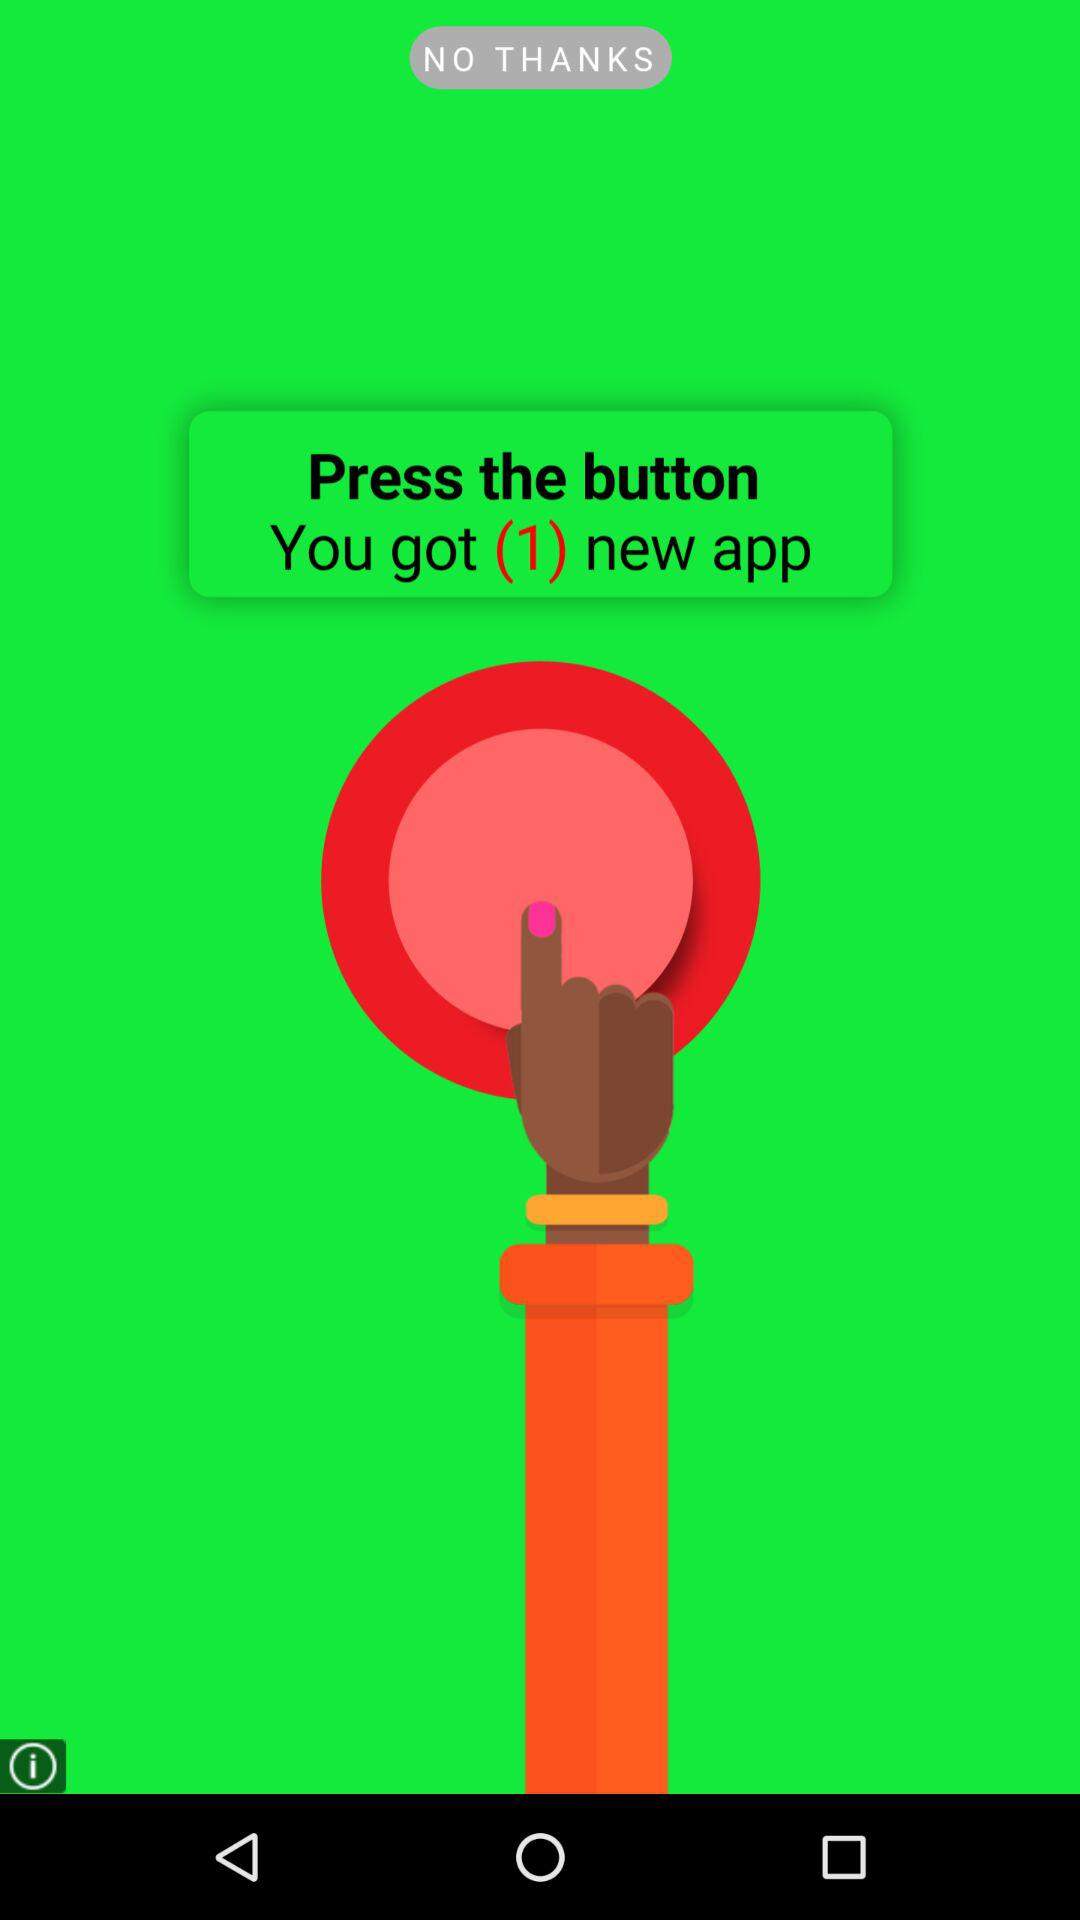How many new applications do we get? You got 1 new application. 